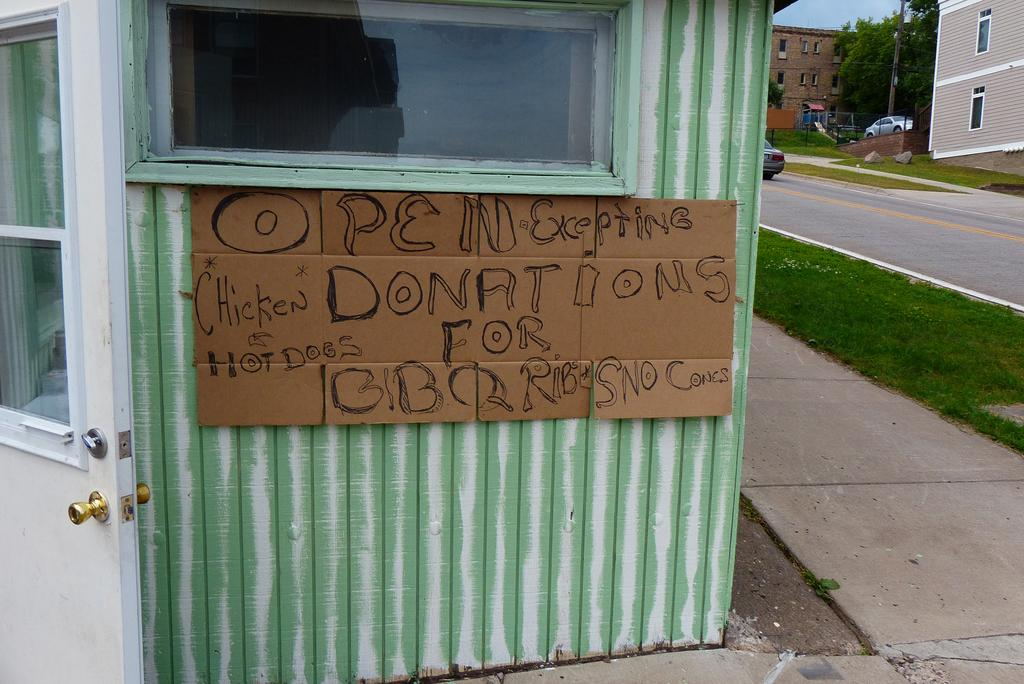What is written or depicted on the cardboard in the image? There is text on a cardboard in the image. What type of natural environment is visible in the background of the image? There is grass in the background of the image. What type of man-made structures can be seen in the background of the image? There are buildings in the background of the image. What type of vegetation is present in the background of the image? There are trees in the background of the image. What type of transportation is visible in the background of the image? There are vehicles in the background of the image. What type of soup is being served with a spoon in the image? There is no soup or spoon present in the image. 